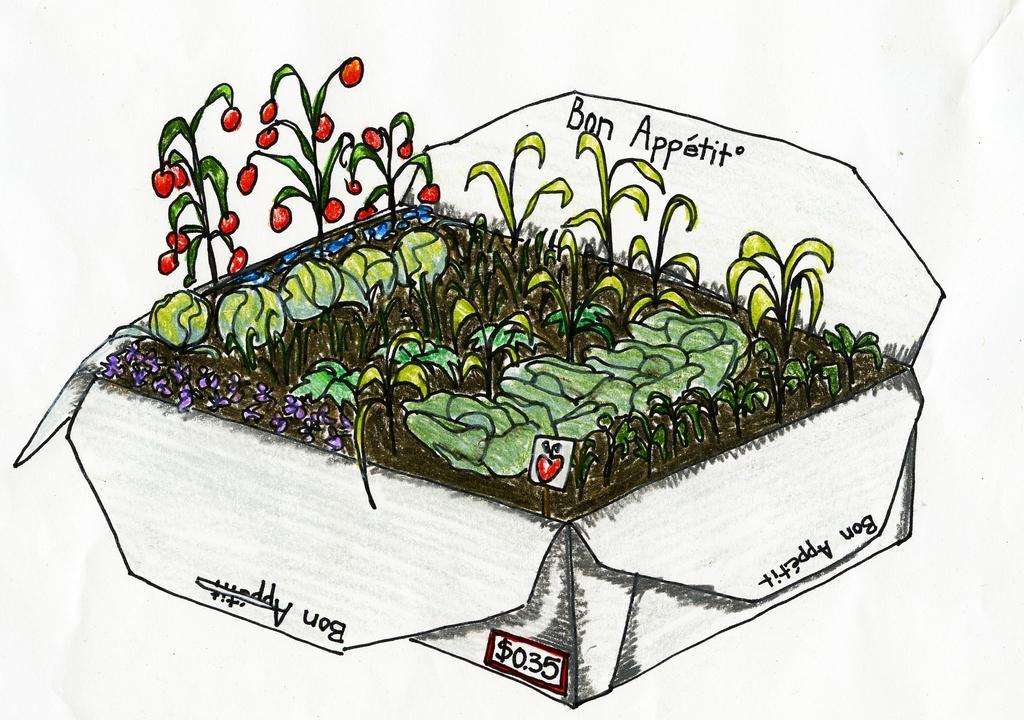Could you give a brief overview of what you see in this image? In this image I can see paintings of houseplants and a text. This image looks like a painting. 